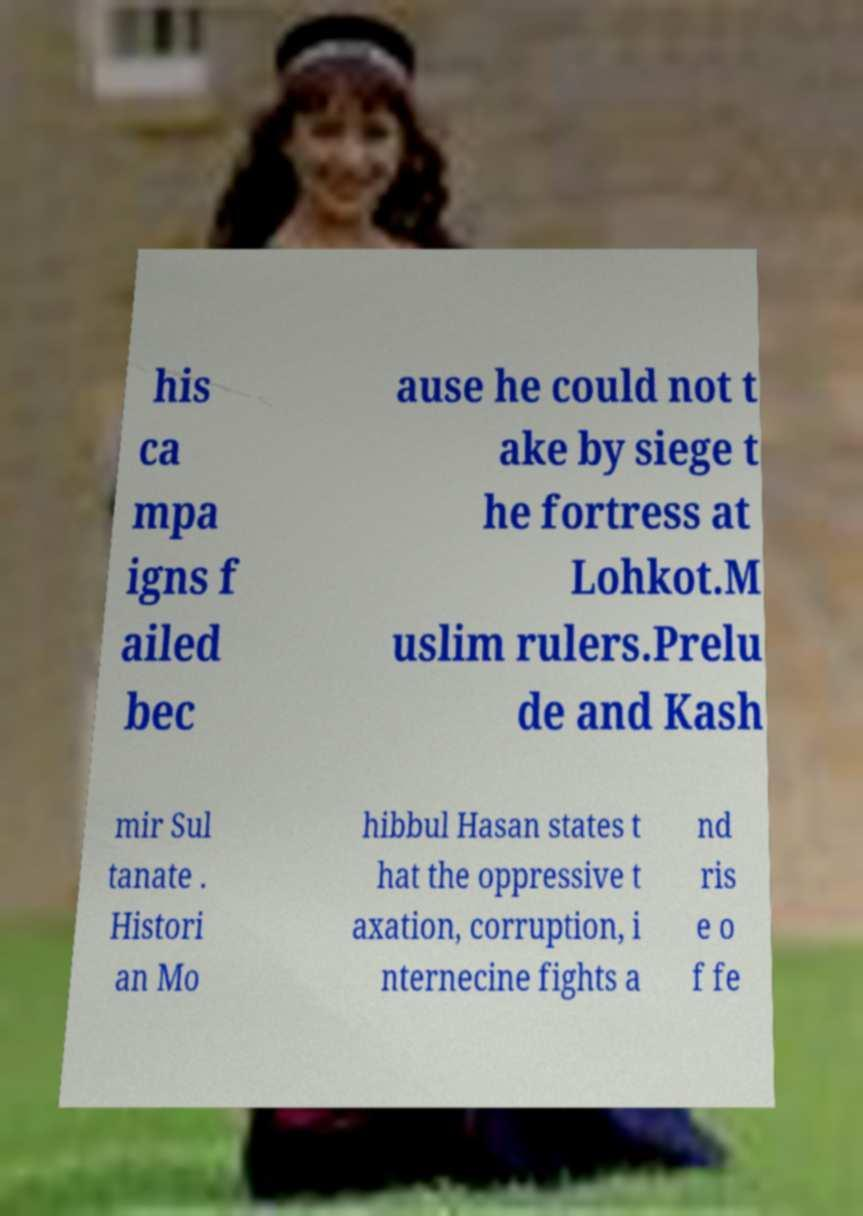What messages or text are displayed in this image? I need them in a readable, typed format. his ca mpa igns f ailed bec ause he could not t ake by siege t he fortress at Lohkot.M uslim rulers.Prelu de and Kash mir Sul tanate . Histori an Mo hibbul Hasan states t hat the oppressive t axation, corruption, i nternecine fights a nd ris e o f fe 